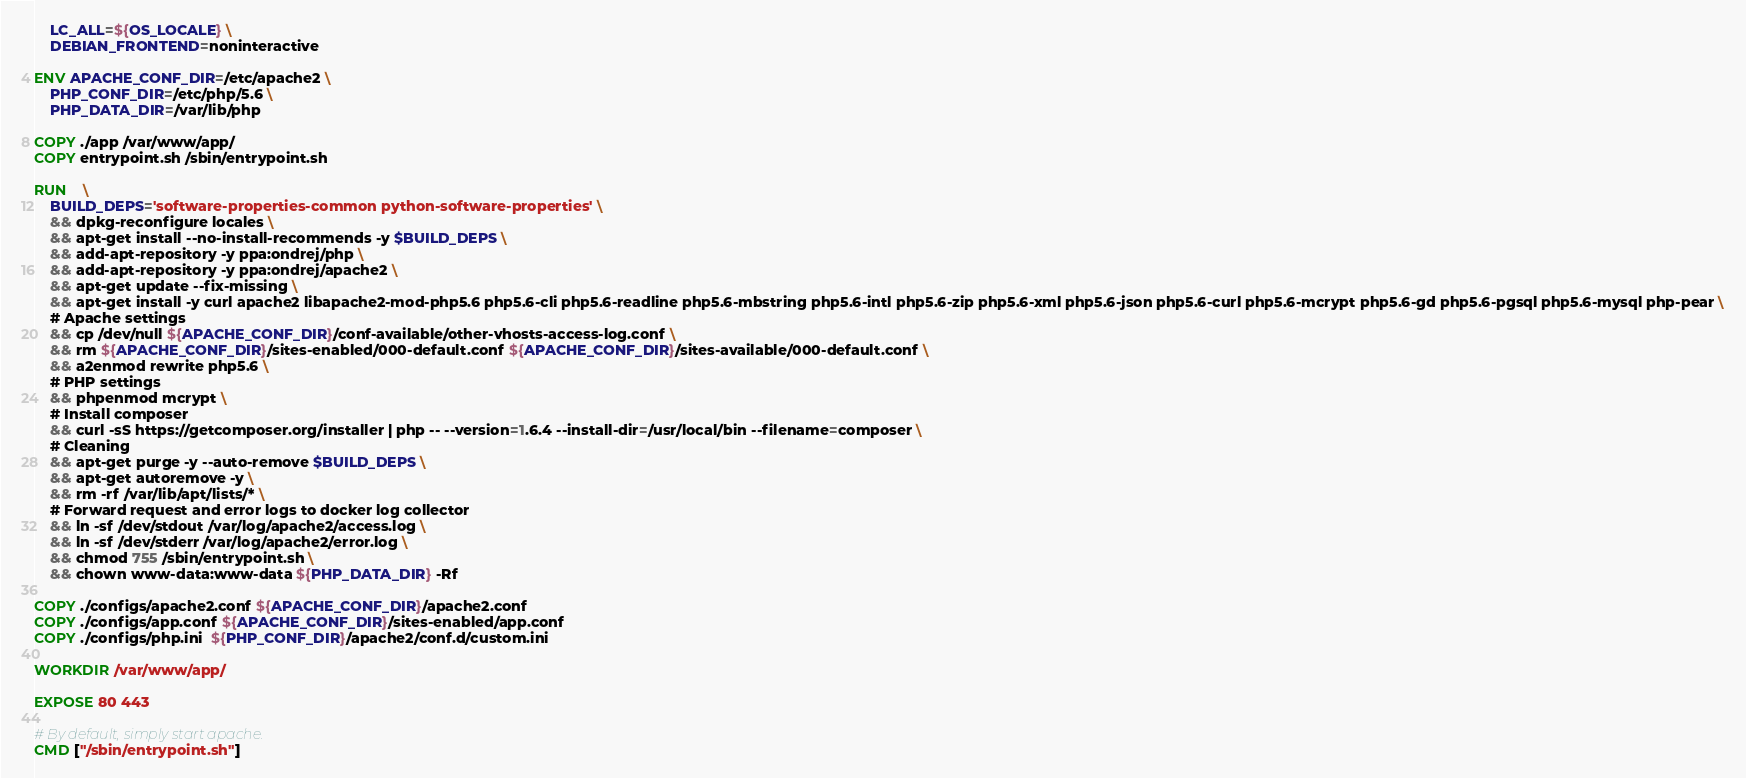Convert code to text. <code><loc_0><loc_0><loc_500><loc_500><_Dockerfile_>    LC_ALL=${OS_LOCALE} \
    DEBIAN_FRONTEND=noninteractive

ENV APACHE_CONF_DIR=/etc/apache2 \
    PHP_CONF_DIR=/etc/php/5.6 \
    PHP_DATA_DIR=/var/lib/php

COPY ./app /var/www/app/
COPY entrypoint.sh /sbin/entrypoint.sh

RUN	\
	BUILD_DEPS='software-properties-common python-software-properties' \
    && dpkg-reconfigure locales \
	&& apt-get install --no-install-recommends -y $BUILD_DEPS \
	&& add-apt-repository -y ppa:ondrej/php \
	&& add-apt-repository -y ppa:ondrej/apache2 \
	&& apt-get update --fix-missing \
    && apt-get install -y curl apache2 libapache2-mod-php5.6 php5.6-cli php5.6-readline php5.6-mbstring php5.6-intl php5.6-zip php5.6-xml php5.6-json php5.6-curl php5.6-mcrypt php5.6-gd php5.6-pgsql php5.6-mysql php-pear \
    # Apache settings
    && cp /dev/null ${APACHE_CONF_DIR}/conf-available/other-vhosts-access-log.conf \
    && rm ${APACHE_CONF_DIR}/sites-enabled/000-default.conf ${APACHE_CONF_DIR}/sites-available/000-default.conf \
    && a2enmod rewrite php5.6 \
    # PHP settings
	&& phpenmod mcrypt \
	# Install composer
	&& curl -sS https://getcomposer.org/installer | php -- --version=1.6.4 --install-dir=/usr/local/bin --filename=composer \
	# Cleaning
	&& apt-get purge -y --auto-remove $BUILD_DEPS \
	&& apt-get autoremove -y \
	&& rm -rf /var/lib/apt/lists/* \
	# Forward request and error logs to docker log collector
	&& ln -sf /dev/stdout /var/log/apache2/access.log \
	&& ln -sf /dev/stderr /var/log/apache2/error.log \
	&& chmod 755 /sbin/entrypoint.sh \
    && chown www-data:www-data ${PHP_DATA_DIR} -Rf

COPY ./configs/apache2.conf ${APACHE_CONF_DIR}/apache2.conf
COPY ./configs/app.conf ${APACHE_CONF_DIR}/sites-enabled/app.conf
COPY ./configs/php.ini  ${PHP_CONF_DIR}/apache2/conf.d/custom.ini

WORKDIR /var/www/app/

EXPOSE 80 443

# By default, simply start apache.
CMD ["/sbin/entrypoint.sh"]</code> 